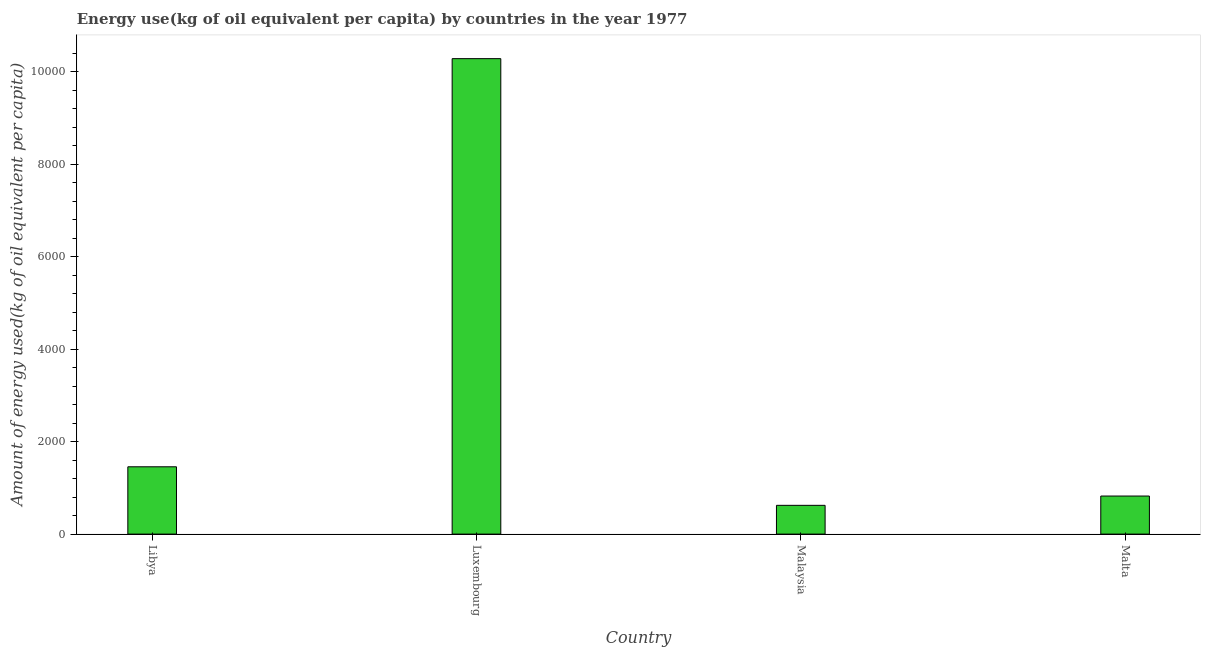Does the graph contain grids?
Provide a succinct answer. No. What is the title of the graph?
Offer a terse response. Energy use(kg of oil equivalent per capita) by countries in the year 1977. What is the label or title of the Y-axis?
Provide a short and direct response. Amount of energy used(kg of oil equivalent per capita). What is the amount of energy used in Libya?
Provide a succinct answer. 1455.08. Across all countries, what is the maximum amount of energy used?
Your answer should be compact. 1.03e+04. Across all countries, what is the minimum amount of energy used?
Make the answer very short. 621.74. In which country was the amount of energy used maximum?
Your answer should be very brief. Luxembourg. In which country was the amount of energy used minimum?
Make the answer very short. Malaysia. What is the sum of the amount of energy used?
Give a very brief answer. 1.32e+04. What is the difference between the amount of energy used in Luxembourg and Malaysia?
Offer a terse response. 9656.82. What is the average amount of energy used per country?
Make the answer very short. 3294.56. What is the median amount of energy used?
Provide a succinct answer. 1138.97. In how many countries, is the amount of energy used greater than 3600 kg?
Give a very brief answer. 1. What is the ratio of the amount of energy used in Malaysia to that in Malta?
Your response must be concise. 0.76. What is the difference between the highest and the second highest amount of energy used?
Provide a short and direct response. 8823.47. What is the difference between the highest and the lowest amount of energy used?
Your answer should be very brief. 9656.82. In how many countries, is the amount of energy used greater than the average amount of energy used taken over all countries?
Offer a terse response. 1. How many bars are there?
Keep it short and to the point. 4. Are all the bars in the graph horizontal?
Make the answer very short. No. How many countries are there in the graph?
Keep it short and to the point. 4. Are the values on the major ticks of Y-axis written in scientific E-notation?
Keep it short and to the point. No. What is the Amount of energy used(kg of oil equivalent per capita) in Libya?
Offer a very short reply. 1455.08. What is the Amount of energy used(kg of oil equivalent per capita) of Luxembourg?
Your answer should be very brief. 1.03e+04. What is the Amount of energy used(kg of oil equivalent per capita) in Malaysia?
Offer a terse response. 621.74. What is the Amount of energy used(kg of oil equivalent per capita) of Malta?
Offer a very short reply. 822.87. What is the difference between the Amount of energy used(kg of oil equivalent per capita) in Libya and Luxembourg?
Your response must be concise. -8823.47. What is the difference between the Amount of energy used(kg of oil equivalent per capita) in Libya and Malaysia?
Keep it short and to the point. 833.34. What is the difference between the Amount of energy used(kg of oil equivalent per capita) in Libya and Malta?
Offer a terse response. 632.22. What is the difference between the Amount of energy used(kg of oil equivalent per capita) in Luxembourg and Malaysia?
Provide a succinct answer. 9656.82. What is the difference between the Amount of energy used(kg of oil equivalent per capita) in Luxembourg and Malta?
Make the answer very short. 9455.69. What is the difference between the Amount of energy used(kg of oil equivalent per capita) in Malaysia and Malta?
Your answer should be compact. -201.13. What is the ratio of the Amount of energy used(kg of oil equivalent per capita) in Libya to that in Luxembourg?
Your response must be concise. 0.14. What is the ratio of the Amount of energy used(kg of oil equivalent per capita) in Libya to that in Malaysia?
Give a very brief answer. 2.34. What is the ratio of the Amount of energy used(kg of oil equivalent per capita) in Libya to that in Malta?
Your response must be concise. 1.77. What is the ratio of the Amount of energy used(kg of oil equivalent per capita) in Luxembourg to that in Malaysia?
Provide a short and direct response. 16.53. What is the ratio of the Amount of energy used(kg of oil equivalent per capita) in Luxembourg to that in Malta?
Your answer should be compact. 12.49. What is the ratio of the Amount of energy used(kg of oil equivalent per capita) in Malaysia to that in Malta?
Ensure brevity in your answer.  0.76. 